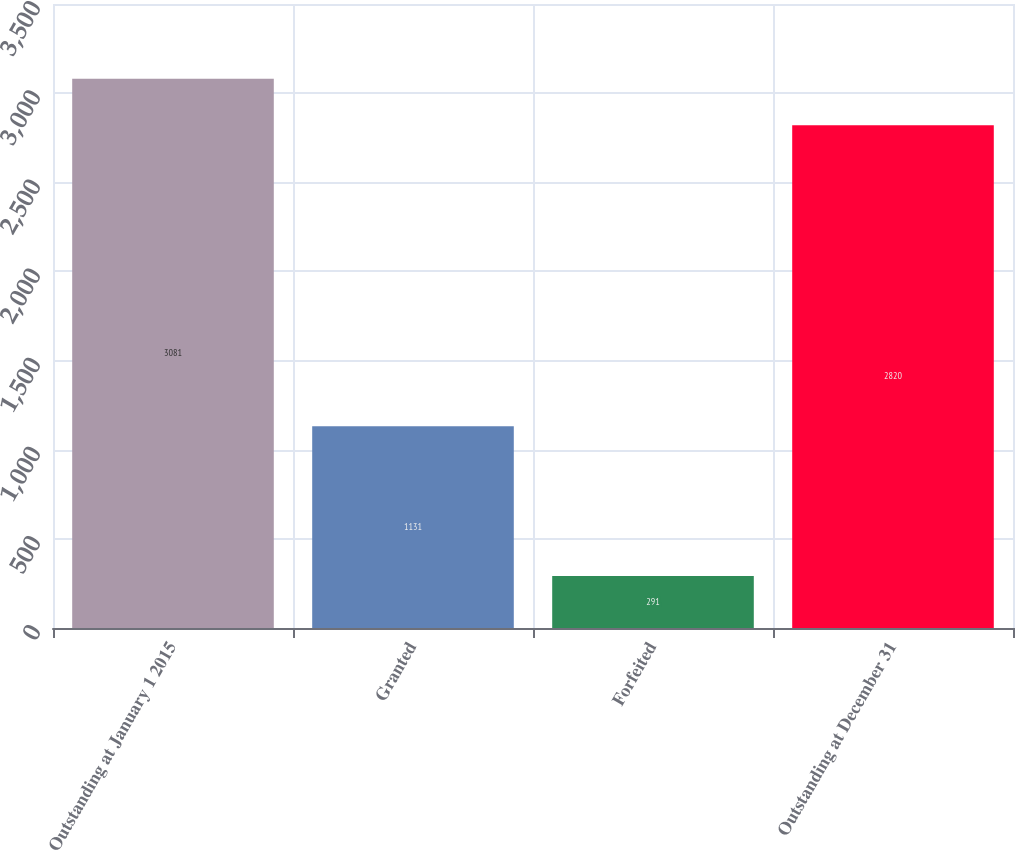Convert chart. <chart><loc_0><loc_0><loc_500><loc_500><bar_chart><fcel>Outstanding at January 1 2015<fcel>Granted<fcel>Forfeited<fcel>Outstanding at December 31<nl><fcel>3081<fcel>1131<fcel>291<fcel>2820<nl></chart> 